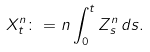<formula> <loc_0><loc_0><loc_500><loc_500>X _ { t } ^ { n } \colon = n \int _ { 0 } ^ { t } Z _ { s } ^ { n } \, d s .</formula> 